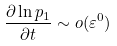<formula> <loc_0><loc_0><loc_500><loc_500>\frac { \partial \ln p _ { 1 } } { \partial t } \sim o ( \varepsilon ^ { 0 } )</formula> 